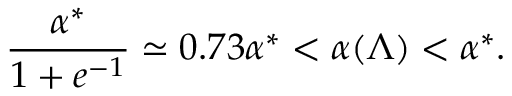<formula> <loc_0><loc_0><loc_500><loc_500>\frac { \alpha ^ { * } } { 1 + e ^ { - 1 } } \simeq 0 . 7 3 \alpha ^ { * } < \alpha ( \Lambda ) < \alpha ^ { * } .</formula> 